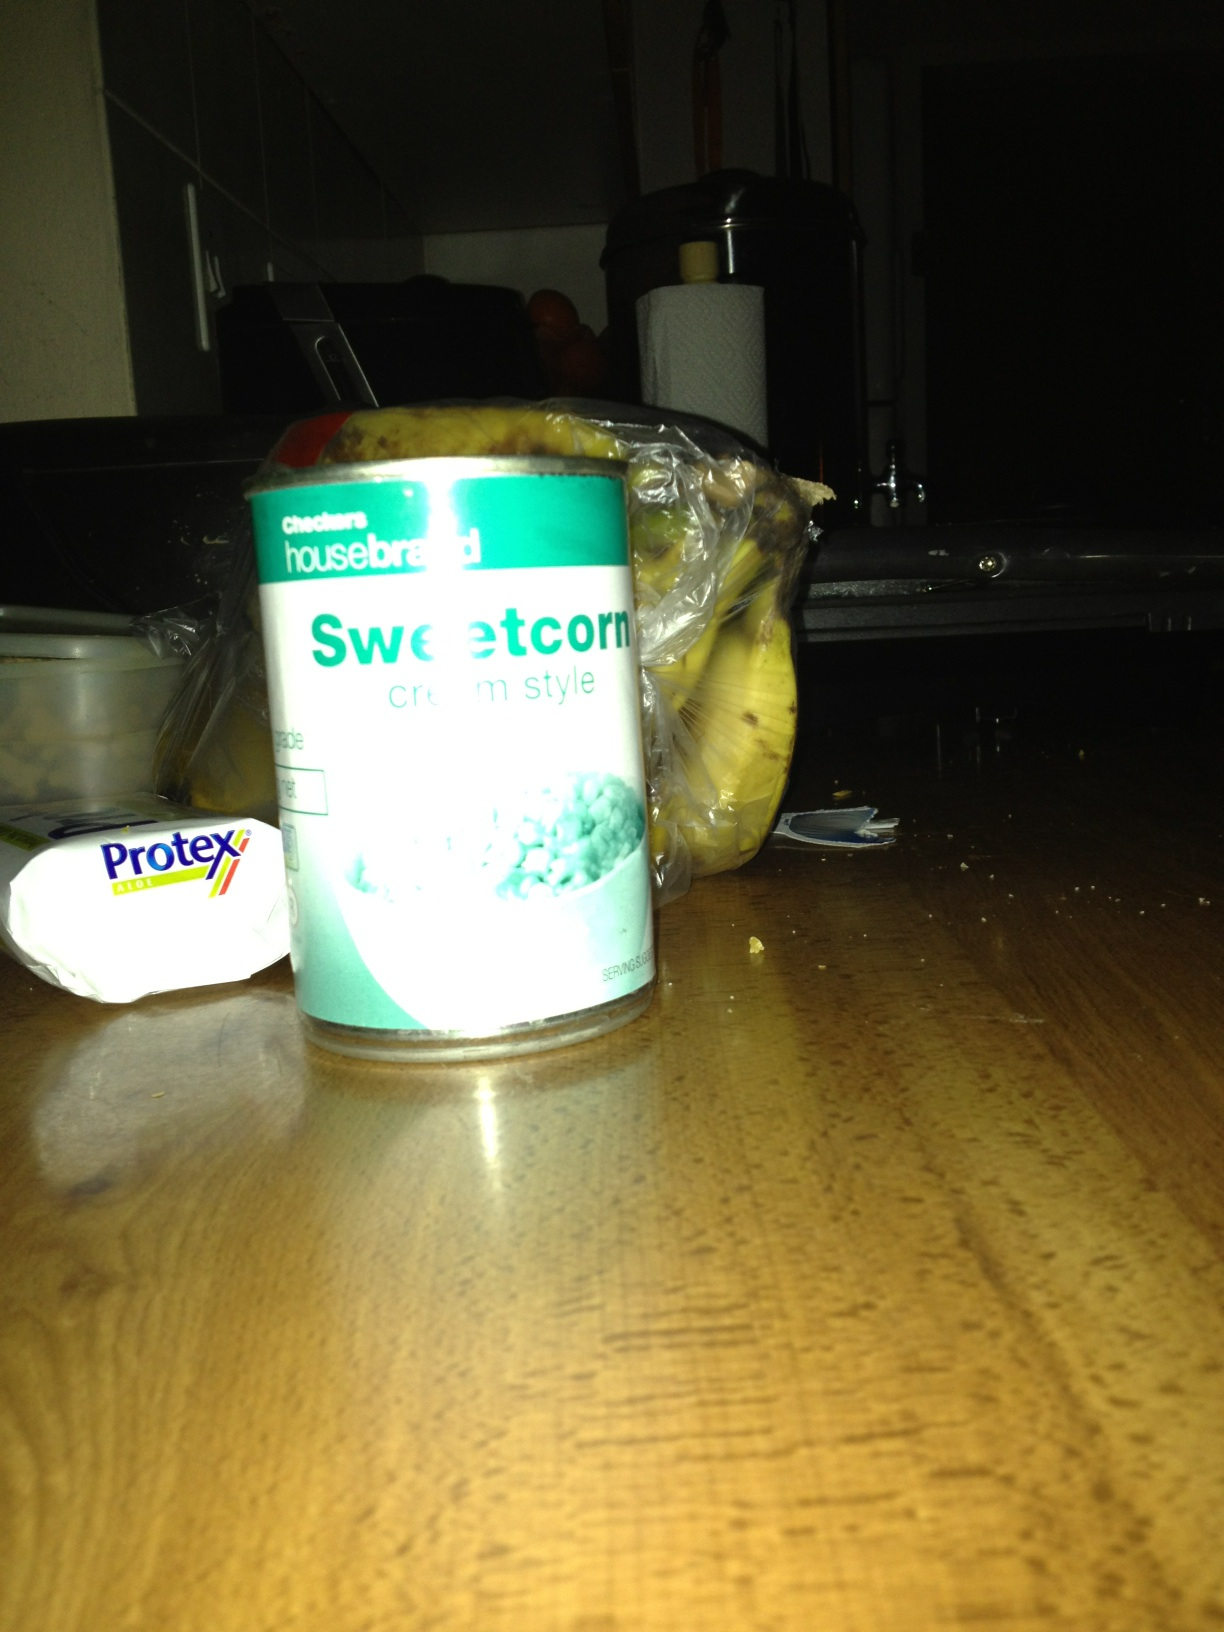How might a chef incorporate this sweetcorn in fine dining? In a fine dining setting, a chef might use this sweetcorn to create an elevated dish like a 'Chilled Sweetcorn Velouté with Lobster Medallions'. The cream style sweetcorn would be blended to a smooth consistency and served as a cold velouté, garnished with tender lobster medallions, a drizzle of truffle oil, and microgreens. This dish would highlight the sweet and creamy nature of the corn, balanced with the rich and delicate flavor of lobster, creating a luxurious and refined appetizer. 